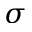<formula> <loc_0><loc_0><loc_500><loc_500>\sigma</formula> 